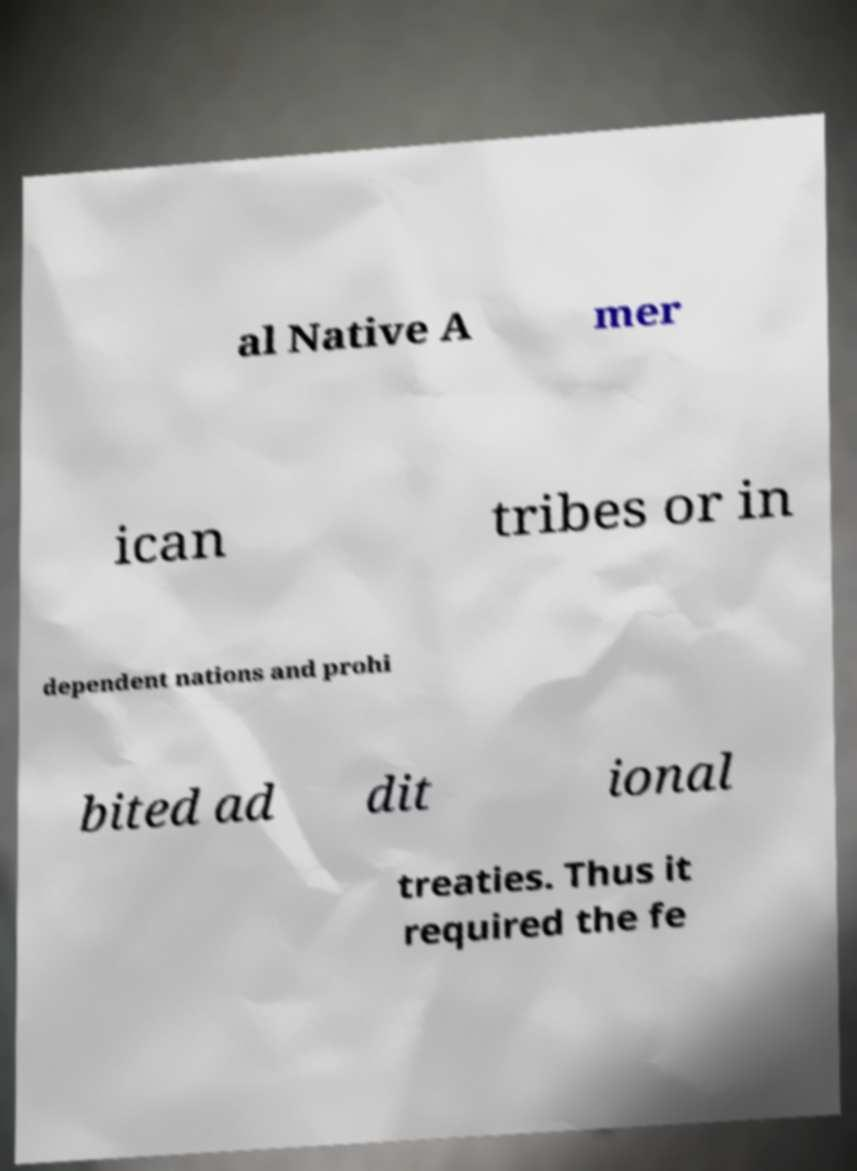There's text embedded in this image that I need extracted. Can you transcribe it verbatim? al Native A mer ican tribes or in dependent nations and prohi bited ad dit ional treaties. Thus it required the fe 